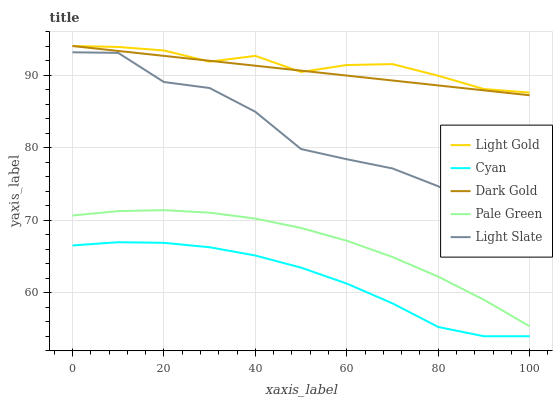Does Cyan have the minimum area under the curve?
Answer yes or no. Yes. Does Light Gold have the maximum area under the curve?
Answer yes or no. Yes. Does Pale Green have the minimum area under the curve?
Answer yes or no. No. Does Pale Green have the maximum area under the curve?
Answer yes or no. No. Is Dark Gold the smoothest?
Answer yes or no. Yes. Is Light Slate the roughest?
Answer yes or no. Yes. Is Cyan the smoothest?
Answer yes or no. No. Is Cyan the roughest?
Answer yes or no. No. Does Cyan have the lowest value?
Answer yes or no. Yes. Does Pale Green have the lowest value?
Answer yes or no. No. Does Dark Gold have the highest value?
Answer yes or no. Yes. Does Pale Green have the highest value?
Answer yes or no. No. Is Pale Green less than Light Slate?
Answer yes or no. Yes. Is Light Gold greater than Pale Green?
Answer yes or no. Yes. Does Light Gold intersect Dark Gold?
Answer yes or no. Yes. Is Light Gold less than Dark Gold?
Answer yes or no. No. Is Light Gold greater than Dark Gold?
Answer yes or no. No. Does Pale Green intersect Light Slate?
Answer yes or no. No. 